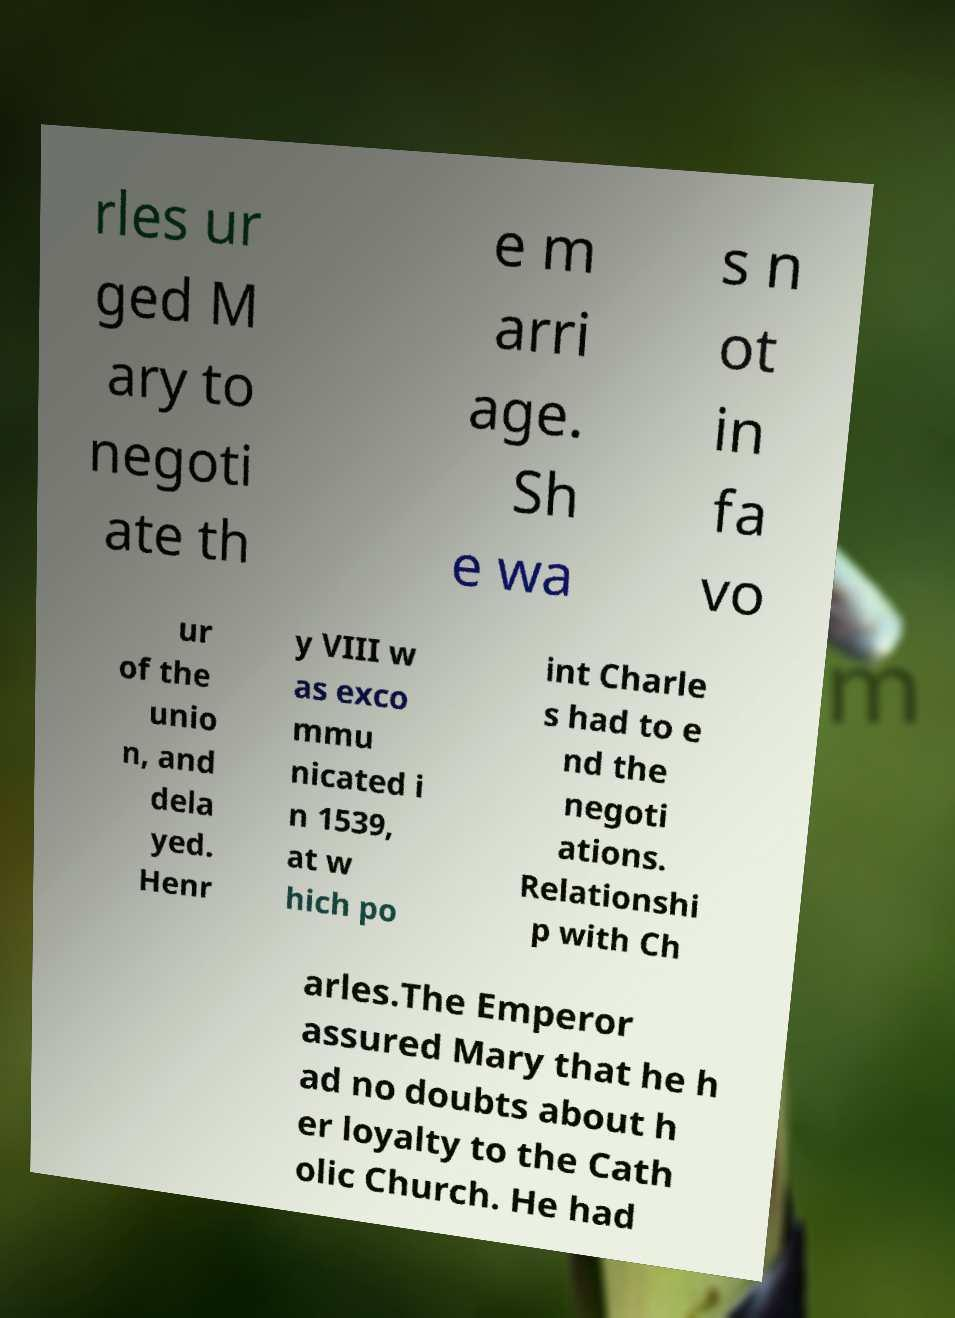What messages or text are displayed in this image? I need them in a readable, typed format. rles ur ged M ary to negoti ate th e m arri age. Sh e wa s n ot in fa vo ur of the unio n, and dela yed. Henr y VIII w as exco mmu nicated i n 1539, at w hich po int Charle s had to e nd the negoti ations. Relationshi p with Ch arles.The Emperor assured Mary that he h ad no doubts about h er loyalty to the Cath olic Church. He had 